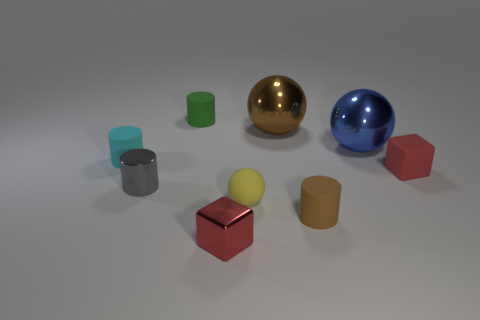Subtract all brown cylinders. How many cylinders are left? 3 Subtract all cyan cylinders. How many cylinders are left? 3 Subtract all cubes. How many objects are left? 7 Add 1 yellow spheres. How many objects exist? 10 Subtract 0 purple cylinders. How many objects are left? 9 Subtract all gray cylinders. Subtract all purple balls. How many cylinders are left? 3 Subtract all tiny blue cylinders. Subtract all green matte objects. How many objects are left? 8 Add 7 big brown metal balls. How many big brown metal balls are left? 8 Add 6 tiny cyan matte cylinders. How many tiny cyan matte cylinders exist? 7 